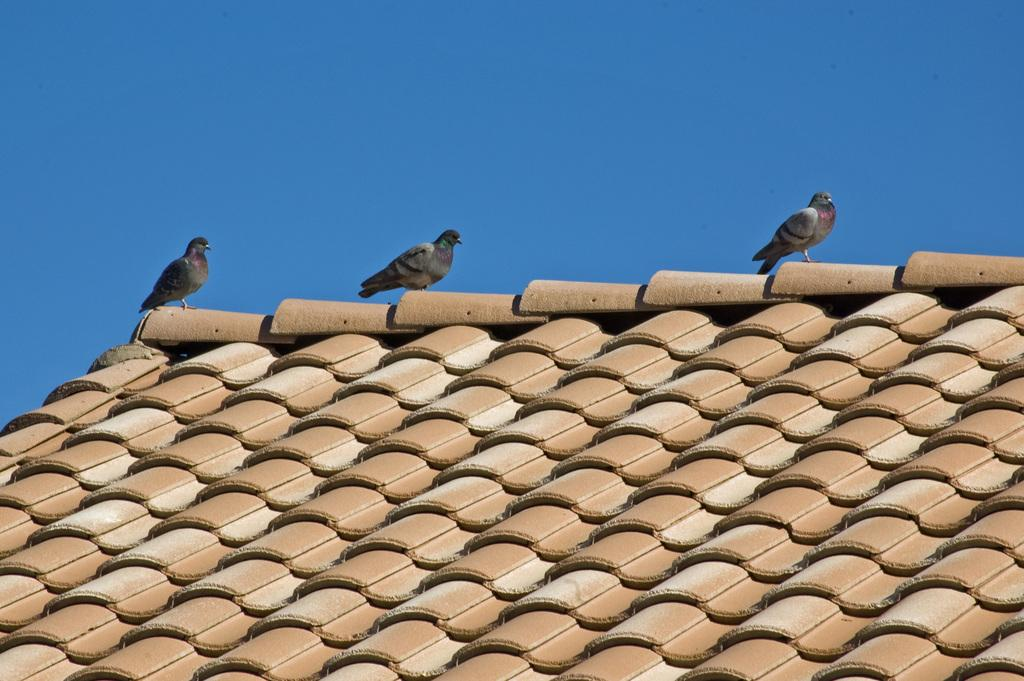What is present on top of the structure in the image? There is a roof in the image. What can be seen on the roof? There are three pigeons standing on the roof. What is visible in the background of the image? The sky is visible in the image. What type of fan is visible on the roof in the image? There is no fan present on the roof in the image. How many teeth can be seen on the pigeons in the image? Pigeons do not have teeth, so there are no teeth visible on the pigeons in the image. 